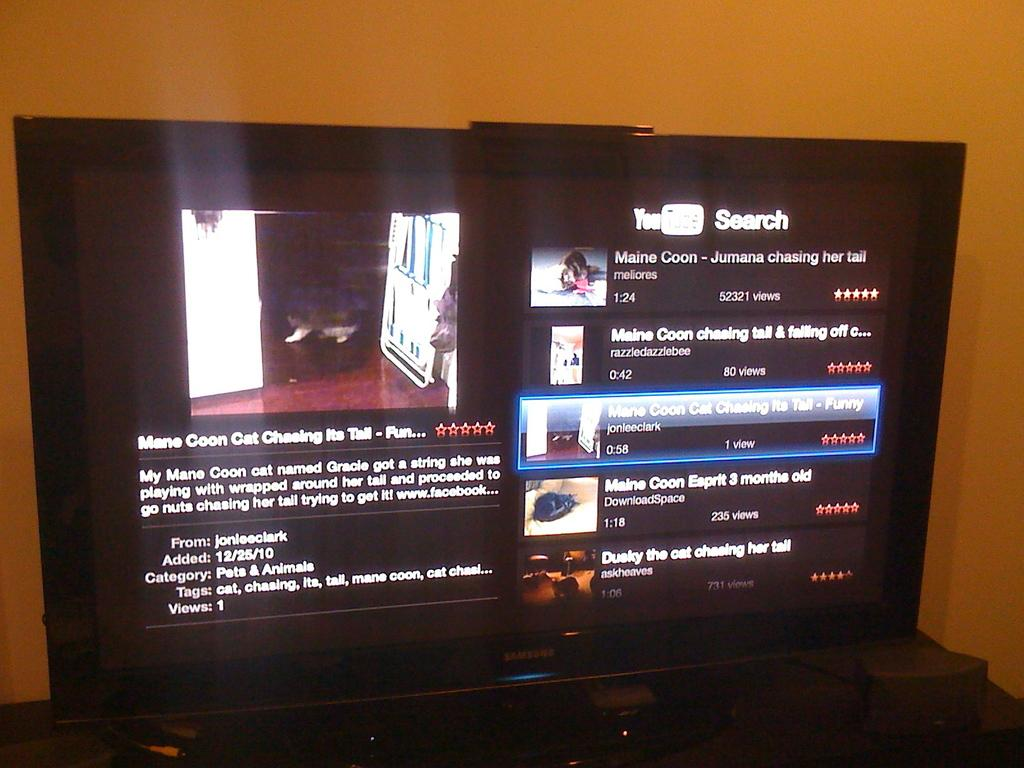<image>
Render a clear and concise summary of the photo. A collection of YouTube videos display search results relating to Maine Coon cats. 